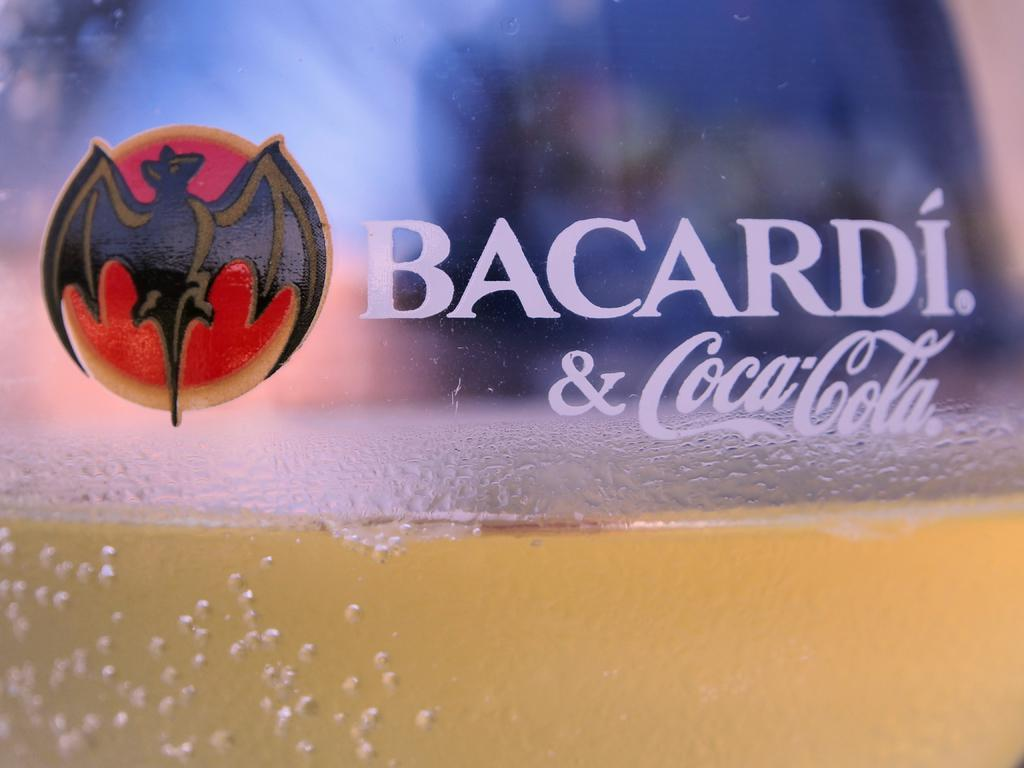<image>
Present a compact description of the photo's key features. a glass of something yellow with bacardi and coca cola inscribed on the glass 